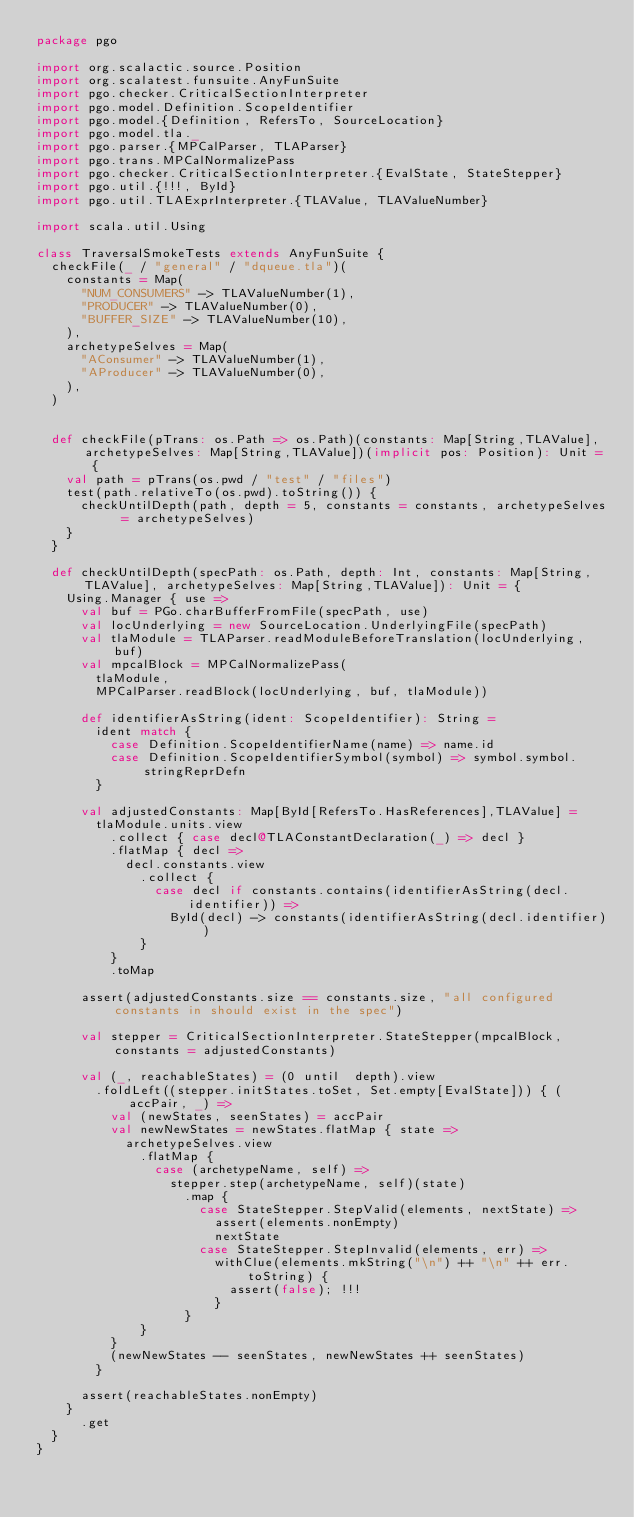Convert code to text. <code><loc_0><loc_0><loc_500><loc_500><_Scala_>package pgo

import org.scalactic.source.Position
import org.scalatest.funsuite.AnyFunSuite
import pgo.checker.CriticalSectionInterpreter
import pgo.model.Definition.ScopeIdentifier
import pgo.model.{Definition, RefersTo, SourceLocation}
import pgo.model.tla._
import pgo.parser.{MPCalParser, TLAParser}
import pgo.trans.MPCalNormalizePass
import pgo.checker.CriticalSectionInterpreter.{EvalState, StateStepper}
import pgo.util.{!!!, ById}
import pgo.util.TLAExprInterpreter.{TLAValue, TLAValueNumber}

import scala.util.Using

class TraversalSmokeTests extends AnyFunSuite {
  checkFile(_ / "general" / "dqueue.tla")(
    constants = Map(
      "NUM_CONSUMERS" -> TLAValueNumber(1),
      "PRODUCER" -> TLAValueNumber(0),
      "BUFFER_SIZE" -> TLAValueNumber(10),
    ),
    archetypeSelves = Map(
      "AConsumer" -> TLAValueNumber(1),
      "AProducer" -> TLAValueNumber(0),
    ),
  )


  def checkFile(pTrans: os.Path => os.Path)(constants: Map[String,TLAValue], archetypeSelves: Map[String,TLAValue])(implicit pos: Position): Unit = {
    val path = pTrans(os.pwd / "test" / "files")
    test(path.relativeTo(os.pwd).toString()) {
      checkUntilDepth(path, depth = 5, constants = constants, archetypeSelves = archetypeSelves)
    }
  }

  def checkUntilDepth(specPath: os.Path, depth: Int, constants: Map[String,TLAValue], archetypeSelves: Map[String,TLAValue]): Unit = {
    Using.Manager { use =>
      val buf = PGo.charBufferFromFile(specPath, use)
      val locUnderlying = new SourceLocation.UnderlyingFile(specPath)
      val tlaModule = TLAParser.readModuleBeforeTranslation(locUnderlying, buf)
      val mpcalBlock = MPCalNormalizePass(
        tlaModule,
        MPCalParser.readBlock(locUnderlying, buf, tlaModule))

      def identifierAsString(ident: ScopeIdentifier): String =
        ident match {
          case Definition.ScopeIdentifierName(name) => name.id
          case Definition.ScopeIdentifierSymbol(symbol) => symbol.symbol.stringReprDefn
        }

      val adjustedConstants: Map[ById[RefersTo.HasReferences],TLAValue] =
        tlaModule.units.view
          .collect { case decl@TLAConstantDeclaration(_) => decl }
          .flatMap { decl =>
            decl.constants.view
              .collect {
                case decl if constants.contains(identifierAsString(decl.identifier)) =>
                  ById(decl) -> constants(identifierAsString(decl.identifier))
              }
          }
          .toMap

      assert(adjustedConstants.size == constants.size, "all configured constants in should exist in the spec")

      val stepper = CriticalSectionInterpreter.StateStepper(mpcalBlock, constants = adjustedConstants)

      val (_, reachableStates) = (0 until  depth).view
        .foldLeft((stepper.initStates.toSet, Set.empty[EvalState])) { (accPair, _) =>
          val (newStates, seenStates) = accPair
          val newNewStates = newStates.flatMap { state =>
            archetypeSelves.view
              .flatMap {
                case (archetypeName, self) =>
                  stepper.step(archetypeName, self)(state)
                    .map {
                      case StateStepper.StepValid(elements, nextState) =>
                        assert(elements.nonEmpty)
                        nextState
                      case StateStepper.StepInvalid(elements, err) =>
                        withClue(elements.mkString("\n") ++ "\n" ++ err.toString) {
                          assert(false); !!!
                        }
                    }
              }
          }
          (newNewStates -- seenStates, newNewStates ++ seenStates)
        }

      assert(reachableStates.nonEmpty)
    }
      .get
  }
}
</code> 